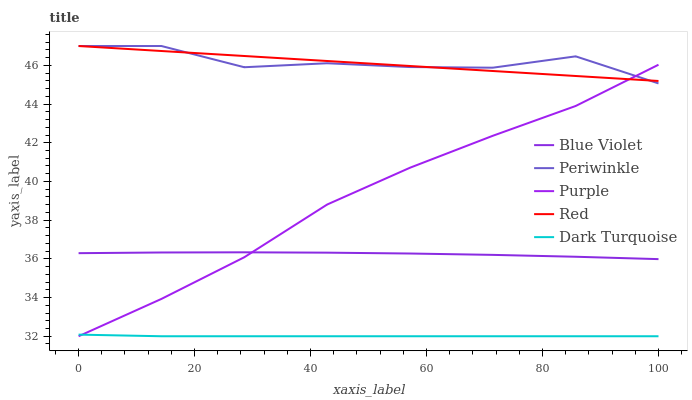Does Dark Turquoise have the minimum area under the curve?
Answer yes or no. Yes. Does Periwinkle have the maximum area under the curve?
Answer yes or no. Yes. Does Periwinkle have the minimum area under the curve?
Answer yes or no. No. Does Dark Turquoise have the maximum area under the curve?
Answer yes or no. No. Is Red the smoothest?
Answer yes or no. Yes. Is Periwinkle the roughest?
Answer yes or no. Yes. Is Dark Turquoise the smoothest?
Answer yes or no. No. Is Dark Turquoise the roughest?
Answer yes or no. No. Does Purple have the lowest value?
Answer yes or no. Yes. Does Periwinkle have the lowest value?
Answer yes or no. No. Does Red have the highest value?
Answer yes or no. Yes. Does Dark Turquoise have the highest value?
Answer yes or no. No. Is Blue Violet less than Red?
Answer yes or no. Yes. Is Periwinkle greater than Blue Violet?
Answer yes or no. Yes. Does Periwinkle intersect Purple?
Answer yes or no. Yes. Is Periwinkle less than Purple?
Answer yes or no. No. Is Periwinkle greater than Purple?
Answer yes or no. No. Does Blue Violet intersect Red?
Answer yes or no. No. 